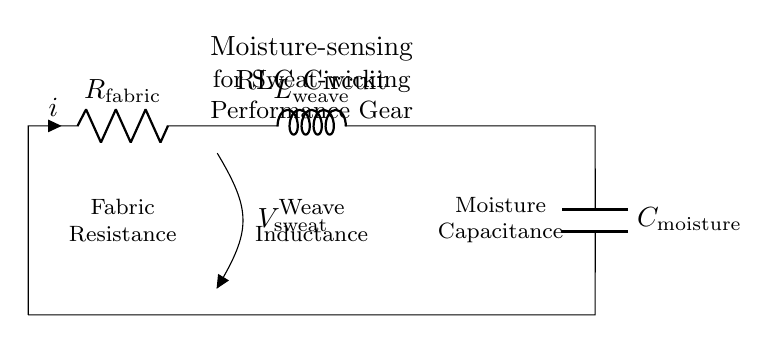What type of circuit is depicted? The circuit shown is an RLC circuit, which consists of a resistor, inductor, and capacitor connected together. This can be identified by the presence of the symbols for these three components.
Answer: RLC circuit What does the capacitor represent in this circuit? The capacitor is labeled as C_air_moisture, indicating its role in sensing moisture levels in the fabric. This suggests that the capacitor accumulates charge affected by the moisture present.
Answer: Moisture capacitance What is the function of the resistance in this RLC circuit? The resistance, labeled R_fabric, provides a measure of how the fabric resists the flow of current. It plays a crucial role in dissipating energy and affects the overall performance of the moisture-sensing circuit.
Answer: Fabric resistance What is the inductor's role in this circuit? The inductor is labeled L_weave, implying it represents the inductance contributed by the fabric's weave structure. This inductance can affect how the circuit responds to changes in moisture.
Answer: Weave inductance What do the components in series indicate about circuit behavior? The components in series suggest that the overall impedance of the circuit is the sum of the individual impedances, affecting the current and voltage characteristics for moisture sensing.
Answer: Series connection What does the voltage source represent in this circuit? The voltage source marked V_sweat indicates the potential difference caused by sweat, which influences the current flowing through the RLC circuit and its response to moisture levels.
Answer: Voltage due to sweat 